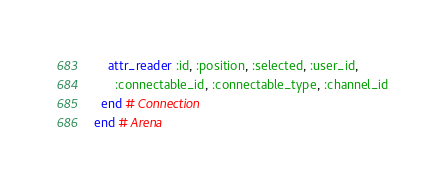<code> <loc_0><loc_0><loc_500><loc_500><_Ruby_>    attr_reader :id, :position, :selected, :user_id,
      :connectable_id, :connectable_type, :channel_id
  end # Connection
end # Arena
</code> 